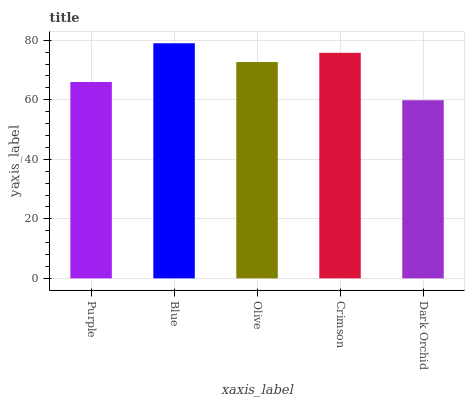Is Olive the minimum?
Answer yes or no. No. Is Olive the maximum?
Answer yes or no. No. Is Blue greater than Olive?
Answer yes or no. Yes. Is Olive less than Blue?
Answer yes or no. Yes. Is Olive greater than Blue?
Answer yes or no. No. Is Blue less than Olive?
Answer yes or no. No. Is Olive the high median?
Answer yes or no. Yes. Is Olive the low median?
Answer yes or no. Yes. Is Blue the high median?
Answer yes or no. No. Is Dark Orchid the low median?
Answer yes or no. No. 